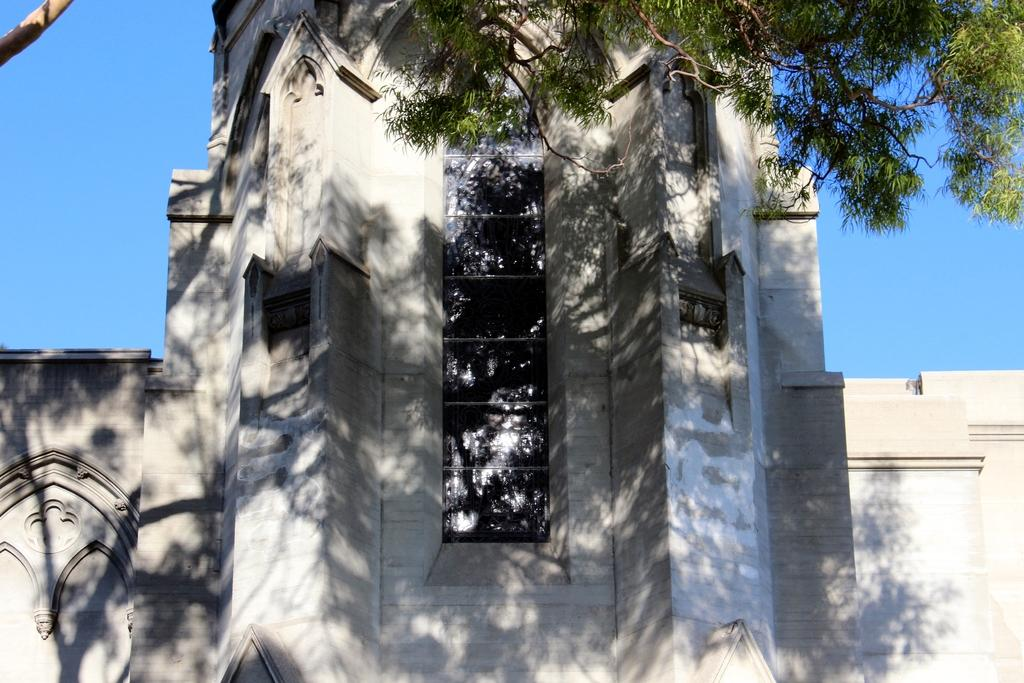What type of vehicle is in the image? There is a white car in the image. What other object can be seen in the image? There is a tree in the image. What color is the sky in the image? The sky is blue in the image. What reason does the pail have for being in the image? There is no pail present in the image, so it cannot have a reason for being there. 